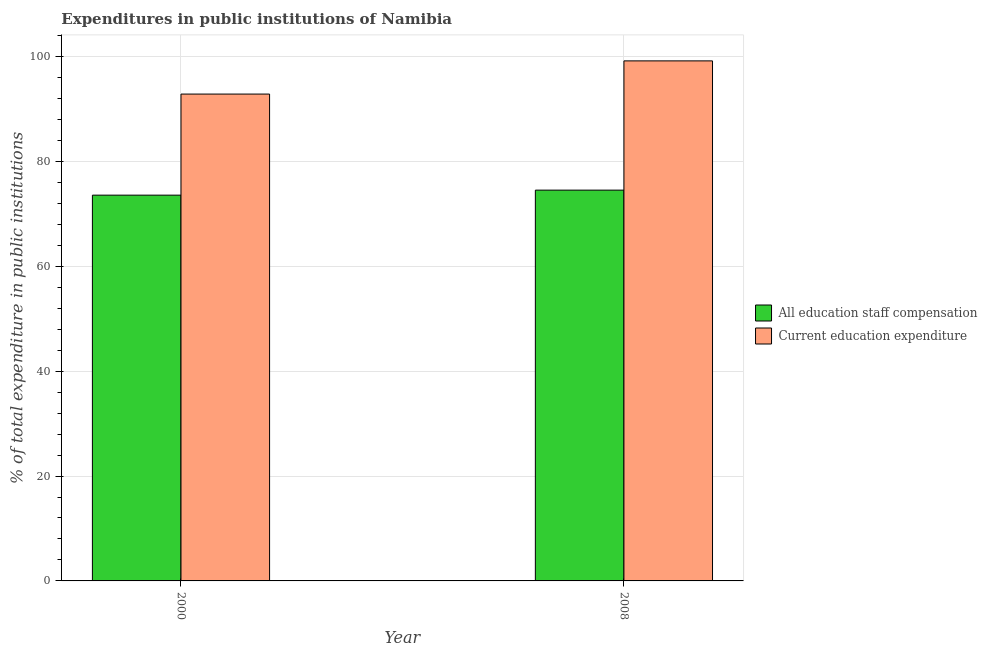Are the number of bars per tick equal to the number of legend labels?
Make the answer very short. Yes. How many bars are there on the 1st tick from the left?
Your response must be concise. 2. What is the label of the 2nd group of bars from the left?
Provide a short and direct response. 2008. In how many cases, is the number of bars for a given year not equal to the number of legend labels?
Make the answer very short. 0. What is the expenditure in education in 2000?
Provide a succinct answer. 92.84. Across all years, what is the maximum expenditure in staff compensation?
Offer a terse response. 74.52. Across all years, what is the minimum expenditure in staff compensation?
Give a very brief answer. 73.56. In which year was the expenditure in education maximum?
Offer a very short reply. 2008. What is the total expenditure in staff compensation in the graph?
Ensure brevity in your answer.  148.09. What is the difference between the expenditure in staff compensation in 2000 and that in 2008?
Your answer should be compact. -0.96. What is the difference between the expenditure in staff compensation in 2000 and the expenditure in education in 2008?
Your answer should be compact. -0.96. What is the average expenditure in staff compensation per year?
Your answer should be very brief. 74.04. In the year 2000, what is the difference between the expenditure in staff compensation and expenditure in education?
Ensure brevity in your answer.  0. What is the ratio of the expenditure in education in 2000 to that in 2008?
Keep it short and to the point. 0.94. Is the expenditure in education in 2000 less than that in 2008?
Give a very brief answer. Yes. What does the 2nd bar from the left in 2008 represents?
Your response must be concise. Current education expenditure. What does the 1st bar from the right in 2000 represents?
Give a very brief answer. Current education expenditure. Are all the bars in the graph horizontal?
Give a very brief answer. No. What is the difference between two consecutive major ticks on the Y-axis?
Give a very brief answer. 20. Are the values on the major ticks of Y-axis written in scientific E-notation?
Your answer should be compact. No. Does the graph contain any zero values?
Provide a succinct answer. No. Does the graph contain grids?
Ensure brevity in your answer.  Yes. Where does the legend appear in the graph?
Offer a terse response. Center right. How many legend labels are there?
Your answer should be compact. 2. What is the title of the graph?
Keep it short and to the point. Expenditures in public institutions of Namibia. What is the label or title of the X-axis?
Your answer should be very brief. Year. What is the label or title of the Y-axis?
Give a very brief answer. % of total expenditure in public institutions. What is the % of total expenditure in public institutions in All education staff compensation in 2000?
Your answer should be very brief. 73.56. What is the % of total expenditure in public institutions of Current education expenditure in 2000?
Keep it short and to the point. 92.84. What is the % of total expenditure in public institutions in All education staff compensation in 2008?
Your response must be concise. 74.52. What is the % of total expenditure in public institutions of Current education expenditure in 2008?
Make the answer very short. 99.17. Across all years, what is the maximum % of total expenditure in public institutions of All education staff compensation?
Offer a terse response. 74.52. Across all years, what is the maximum % of total expenditure in public institutions in Current education expenditure?
Give a very brief answer. 99.17. Across all years, what is the minimum % of total expenditure in public institutions in All education staff compensation?
Keep it short and to the point. 73.56. Across all years, what is the minimum % of total expenditure in public institutions of Current education expenditure?
Provide a succinct answer. 92.84. What is the total % of total expenditure in public institutions of All education staff compensation in the graph?
Offer a terse response. 148.09. What is the total % of total expenditure in public institutions of Current education expenditure in the graph?
Your response must be concise. 192.01. What is the difference between the % of total expenditure in public institutions in All education staff compensation in 2000 and that in 2008?
Offer a terse response. -0.96. What is the difference between the % of total expenditure in public institutions of Current education expenditure in 2000 and that in 2008?
Give a very brief answer. -6.33. What is the difference between the % of total expenditure in public institutions of All education staff compensation in 2000 and the % of total expenditure in public institutions of Current education expenditure in 2008?
Your answer should be compact. -25.61. What is the average % of total expenditure in public institutions of All education staff compensation per year?
Your response must be concise. 74.04. What is the average % of total expenditure in public institutions in Current education expenditure per year?
Give a very brief answer. 96. In the year 2000, what is the difference between the % of total expenditure in public institutions in All education staff compensation and % of total expenditure in public institutions in Current education expenditure?
Offer a terse response. -19.28. In the year 2008, what is the difference between the % of total expenditure in public institutions in All education staff compensation and % of total expenditure in public institutions in Current education expenditure?
Give a very brief answer. -24.65. What is the ratio of the % of total expenditure in public institutions of All education staff compensation in 2000 to that in 2008?
Your answer should be compact. 0.99. What is the ratio of the % of total expenditure in public institutions in Current education expenditure in 2000 to that in 2008?
Give a very brief answer. 0.94. What is the difference between the highest and the second highest % of total expenditure in public institutions of All education staff compensation?
Your answer should be very brief. 0.96. What is the difference between the highest and the second highest % of total expenditure in public institutions in Current education expenditure?
Offer a terse response. 6.33. What is the difference between the highest and the lowest % of total expenditure in public institutions in All education staff compensation?
Ensure brevity in your answer.  0.96. What is the difference between the highest and the lowest % of total expenditure in public institutions of Current education expenditure?
Offer a very short reply. 6.33. 